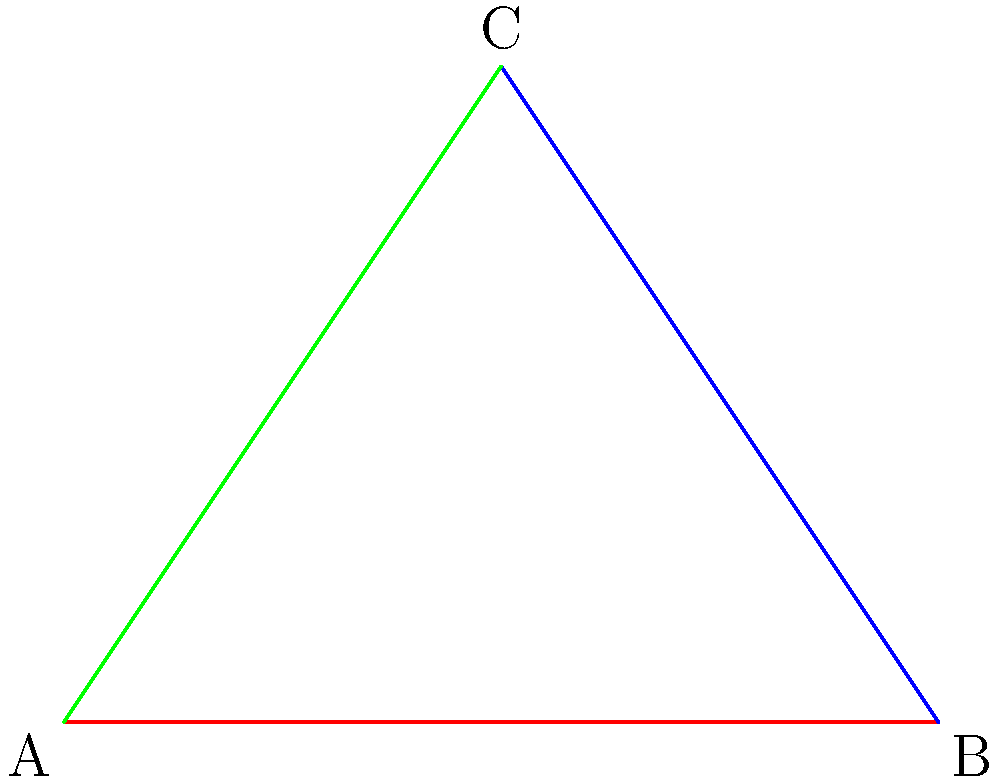Look at the colorful triangle! Can you count how many sides are colored? Let's count the sides of the triangle together:

1. First, we see a red line at the bottom of the triangle.
2. Then, we see a blue line on the right side of the triangle.
3. Finally, we see a green line on the left side of the triangle.

When we count these colored lines, we get:
1 (red) + 1 (blue) + 1 (green) = 3 colored sides

So, the triangle has 3 colored sides in total.
Answer: 3 sides 